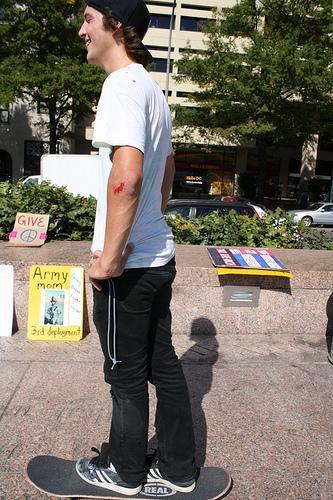How many people are in the photo?
Give a very brief answer. 1. How many trees are in the photo?
Give a very brief answer. 2. How many times has the army Mom been deployed?
Give a very brief answer. 3. How many trees are on the left of the man on skateboard?
Give a very brief answer. 1. 